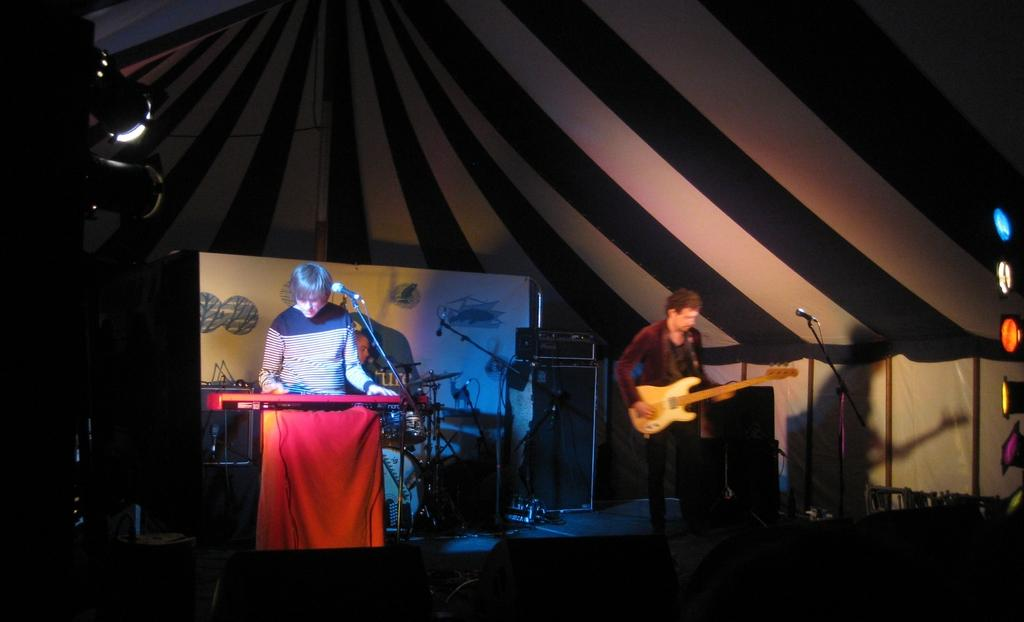What are the two men in the image doing? There is a man standing and playing a piano, and another man standing and playing a guitar. What can be seen in the background of the image? There is light in the background. Is there any furniture in the image? Yes, there is a chair in the image. What type of humor can be seen in the glass on the table in the image? There is no glass or table present in the image, and therefore no humor can be observed. 